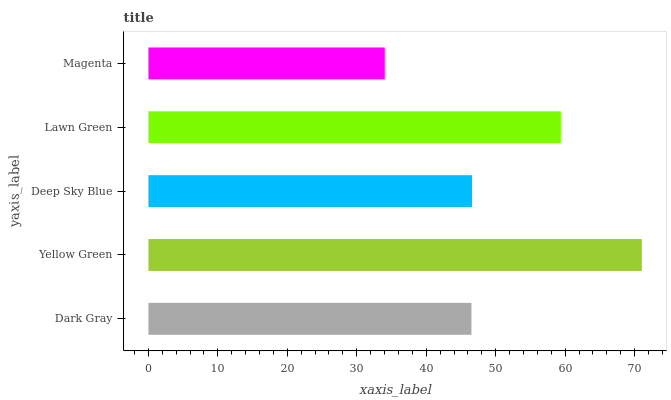Is Magenta the minimum?
Answer yes or no. Yes. Is Yellow Green the maximum?
Answer yes or no. Yes. Is Deep Sky Blue the minimum?
Answer yes or no. No. Is Deep Sky Blue the maximum?
Answer yes or no. No. Is Yellow Green greater than Deep Sky Blue?
Answer yes or no. Yes. Is Deep Sky Blue less than Yellow Green?
Answer yes or no. Yes. Is Deep Sky Blue greater than Yellow Green?
Answer yes or no. No. Is Yellow Green less than Deep Sky Blue?
Answer yes or no. No. Is Deep Sky Blue the high median?
Answer yes or no. Yes. Is Deep Sky Blue the low median?
Answer yes or no. Yes. Is Lawn Green the high median?
Answer yes or no. No. Is Lawn Green the low median?
Answer yes or no. No. 